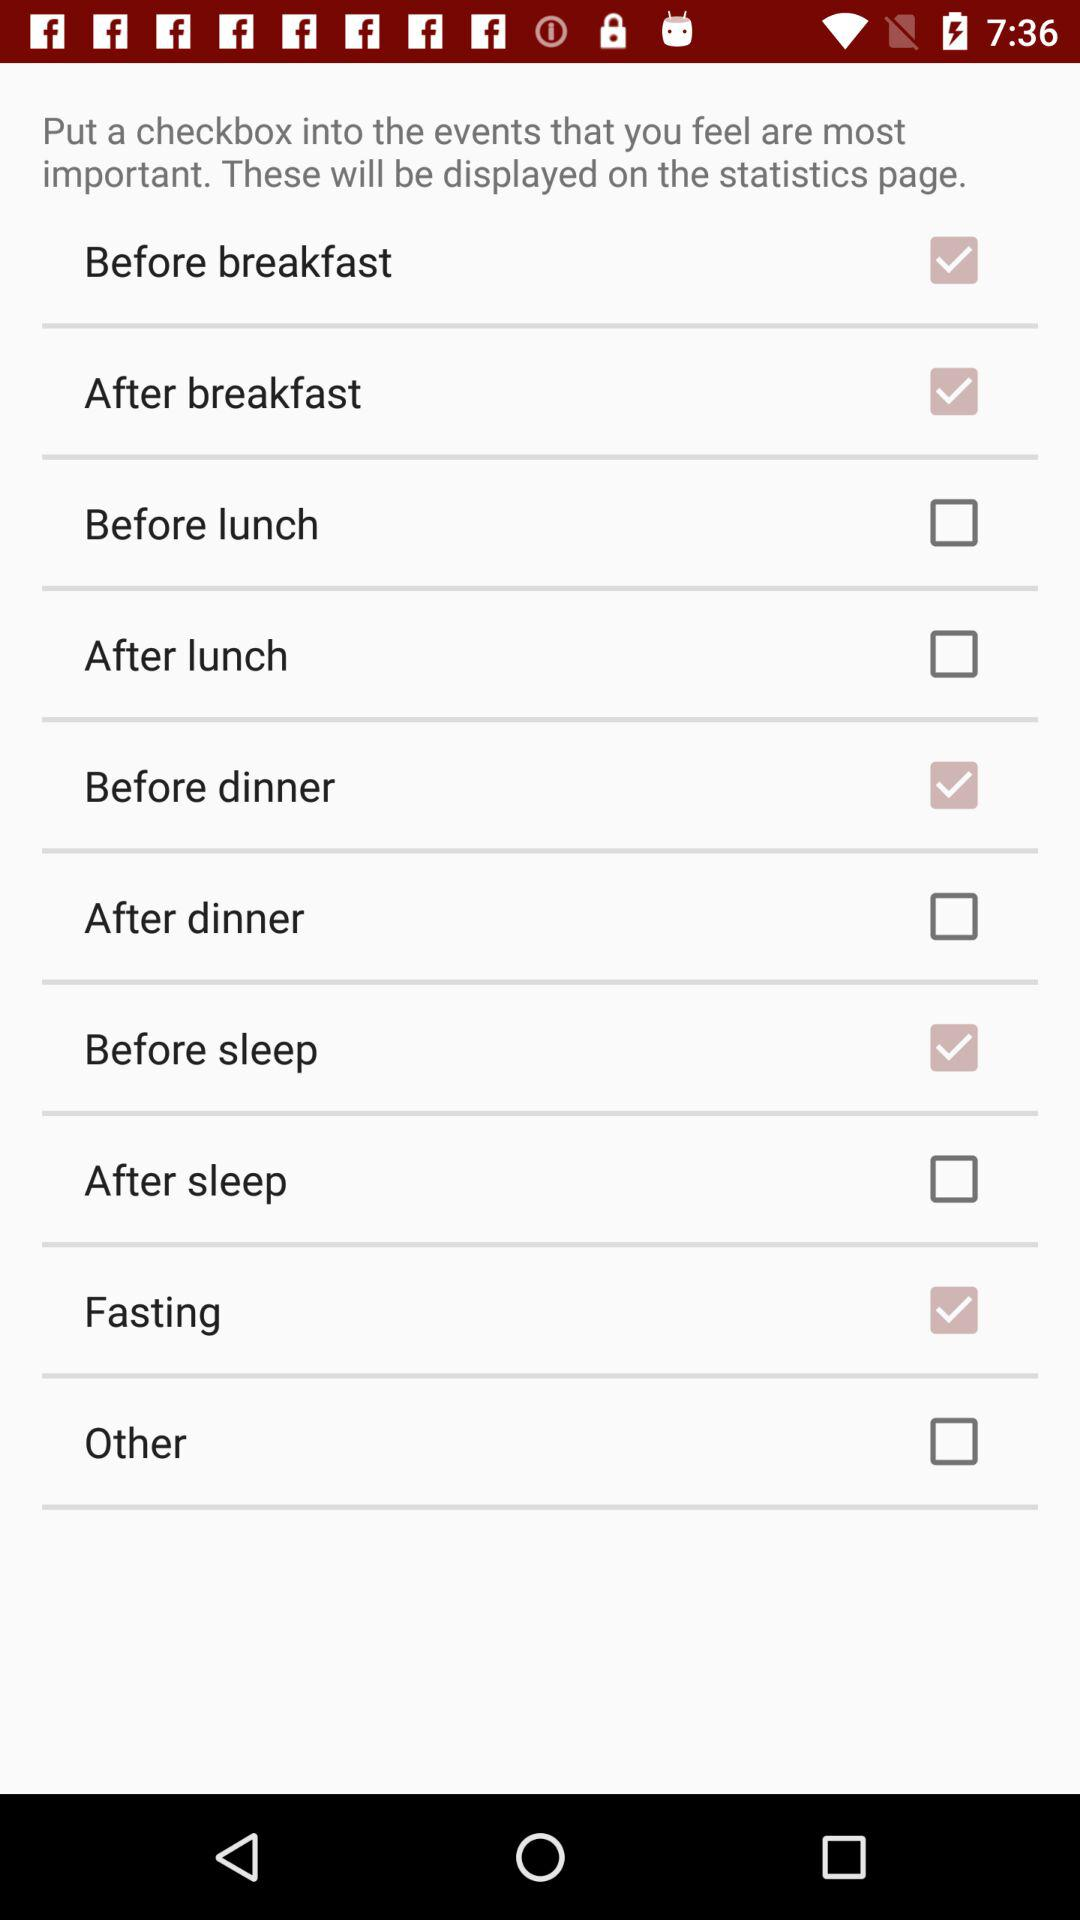What checkbox is checked? The checked checkboxes are "Before breakfast", "After breakfast", "Before dinner", "Before sleep" and "Fasting". 